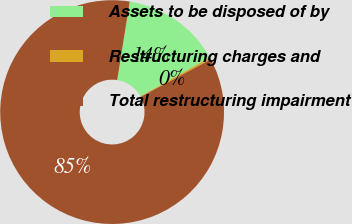Convert chart to OTSL. <chart><loc_0><loc_0><loc_500><loc_500><pie_chart><fcel>Assets to be disposed of by<fcel>Restructuring charges and<fcel>Total restructuring impairment<nl><fcel>14.4%<fcel>0.29%<fcel>85.31%<nl></chart> 